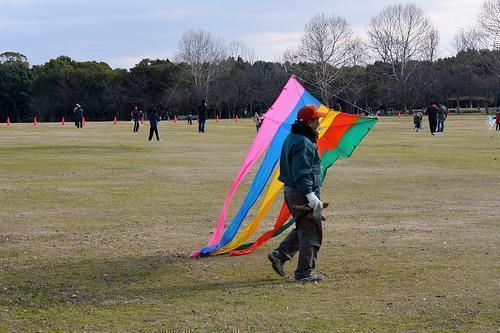Which color of the rainbow is missing from this kite?
Select the accurate response from the four choices given to answer the question.
Options: Brown, blue, green, yellow. Yellow. 